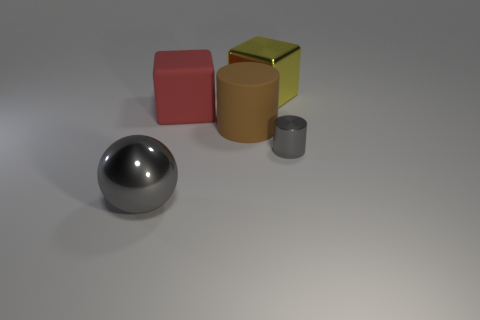Are there any other things that have the same shape as the big gray shiny object?
Offer a terse response. No. There is a big red rubber object; what shape is it?
Ensure brevity in your answer.  Cube. What color is the thing that is in front of the small gray cylinder?
Keep it short and to the point. Gray. Do the metallic object behind the metal cylinder and the tiny metallic cylinder have the same size?
Give a very brief answer. No. The other thing that is the same shape as the brown thing is what size?
Provide a short and direct response. Small. Is there anything else that has the same size as the gray cylinder?
Your answer should be compact. No. Is the tiny shiny object the same shape as the large brown object?
Your answer should be compact. Yes. Are there fewer small shiny cylinders behind the large brown cylinder than shiny objects that are on the left side of the large yellow shiny block?
Offer a terse response. Yes. What number of matte blocks are behind the gray cylinder?
Your response must be concise. 1. There is a large metallic object that is to the right of the sphere; is its shape the same as the large rubber object left of the large cylinder?
Provide a succinct answer. Yes. 